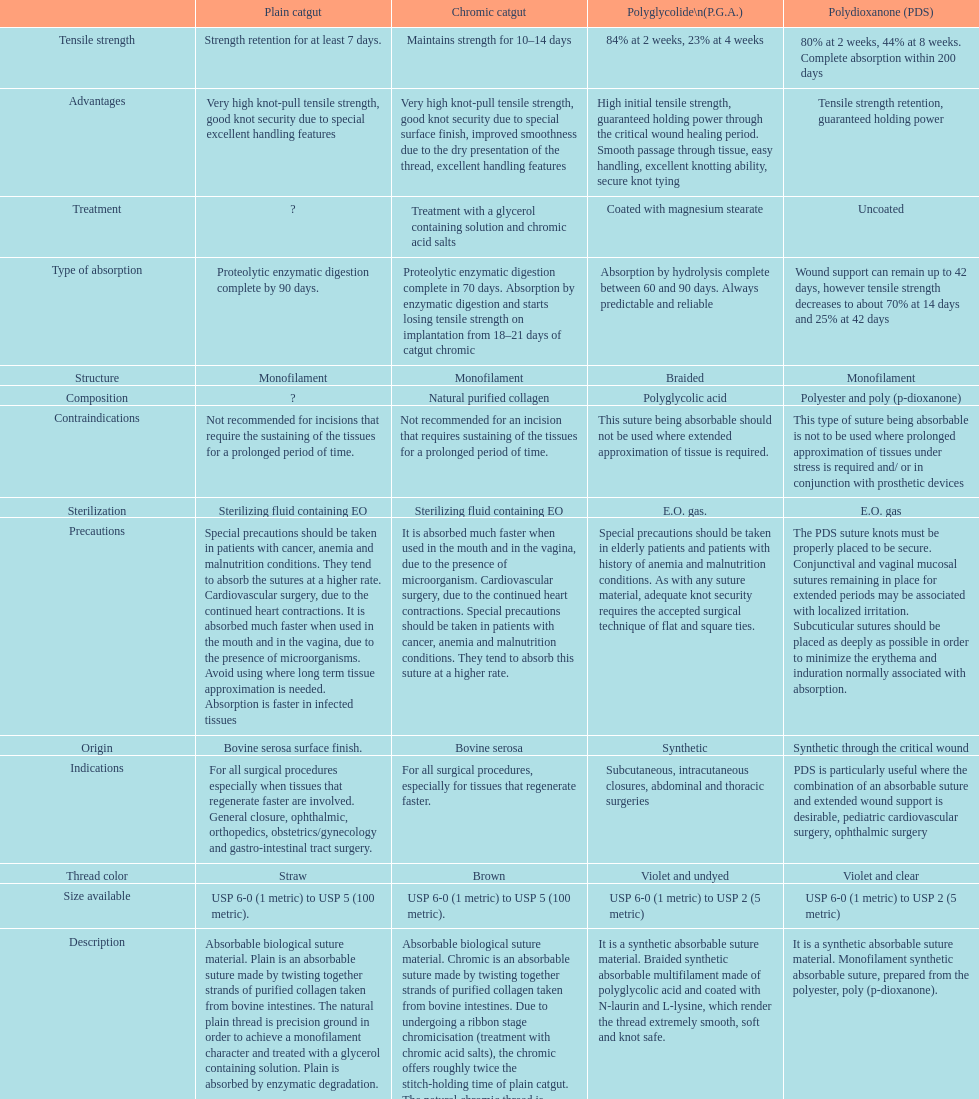The plain catgut maintains its strength for at least how many number of days? Strength retention for at least 7 days. 